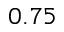Convert formula to latex. <formula><loc_0><loc_0><loc_500><loc_500>0 . 7 5</formula> 